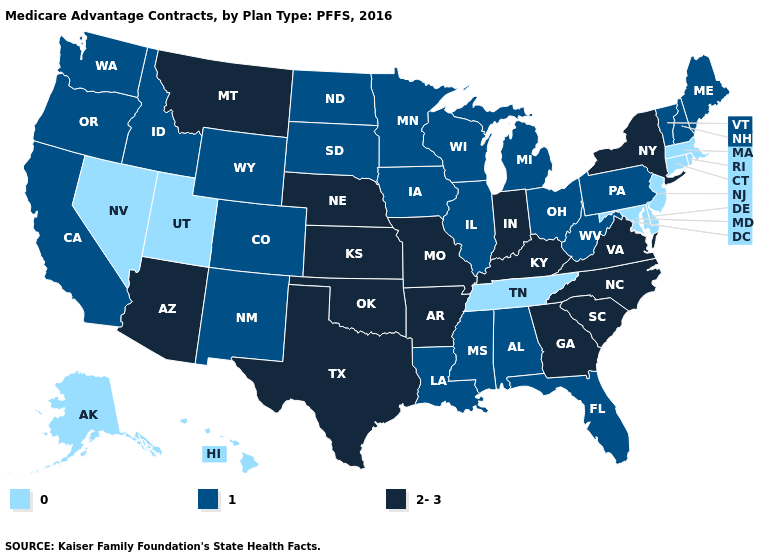Does Illinois have the same value as Louisiana?
Be succinct. Yes. What is the value of New Jersey?
Concise answer only. 0. What is the value of Tennessee?
Answer briefly. 0. Does Minnesota have a lower value than Indiana?
Write a very short answer. Yes. What is the value of Michigan?
Concise answer only. 1. Does Colorado have a lower value than Kansas?
Give a very brief answer. Yes. What is the lowest value in states that border Minnesota?
Answer briefly. 1. What is the lowest value in the MidWest?
Be succinct. 1. Does Texas have the highest value in the USA?
Be succinct. Yes. What is the value of New Jersey?
Give a very brief answer. 0. What is the value of Virginia?
Keep it brief. 2-3. Does Kentucky have the highest value in the USA?
Quick response, please. Yes. What is the lowest value in the USA?
Give a very brief answer. 0. Which states have the lowest value in the MidWest?
Give a very brief answer. Iowa, Illinois, Michigan, Minnesota, North Dakota, Ohio, South Dakota, Wisconsin. Name the states that have a value in the range 2-3?
Short answer required. Arkansas, Arizona, Georgia, Indiana, Kansas, Kentucky, Missouri, Montana, North Carolina, Nebraska, New York, Oklahoma, South Carolina, Texas, Virginia. 